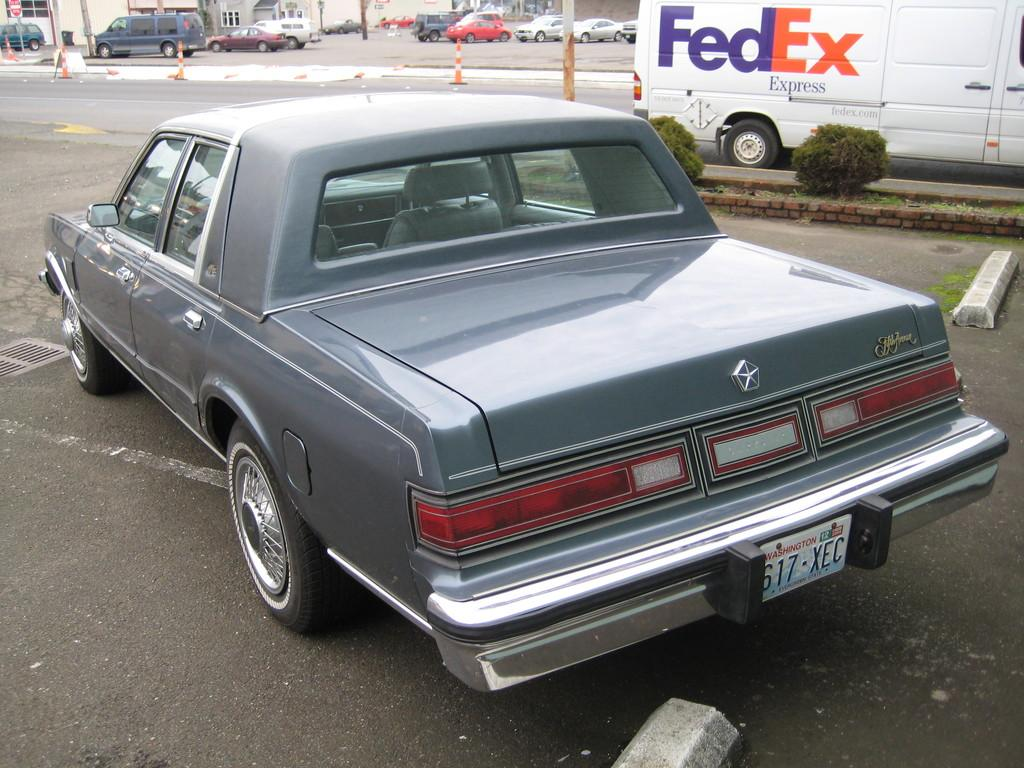What is parked on the road in the image? There is a car parked on the road in the image. What else can be seen in the image besides the car? There are plants, vehicles, divider poles, and a building with windows visible in the image. Can you describe the plants in the image? The plants are visible in the image, but their specific type or characteristics are not mentioned in the provided facts. What is the building with windows used for? The purpose of the building with windows is not mentioned in the provided facts. What type of skin can be seen on the face of the person in the image? There is no person or face visible in the image; it features a car parked on the road, plants, vehicles, divider poles, and a building with windows. 